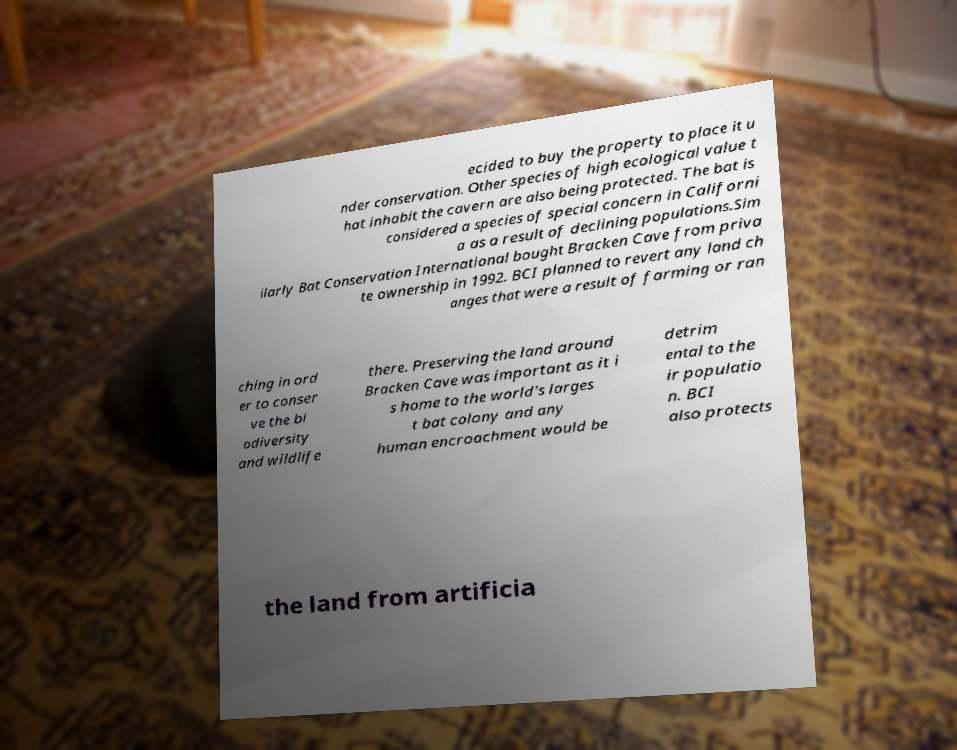Please identify and transcribe the text found in this image. ecided to buy the property to place it u nder conservation. Other species of high ecological value t hat inhabit the cavern are also being protected. The bat is considered a species of special concern in Californi a as a result of declining populations.Sim ilarly Bat Conservation International bought Bracken Cave from priva te ownership in 1992. BCI planned to revert any land ch anges that were a result of farming or ran ching in ord er to conser ve the bi odiversity and wildlife there. Preserving the land around Bracken Cave was important as it i s home to the world's larges t bat colony and any human encroachment would be detrim ental to the ir populatio n. BCI also protects the land from artificia 